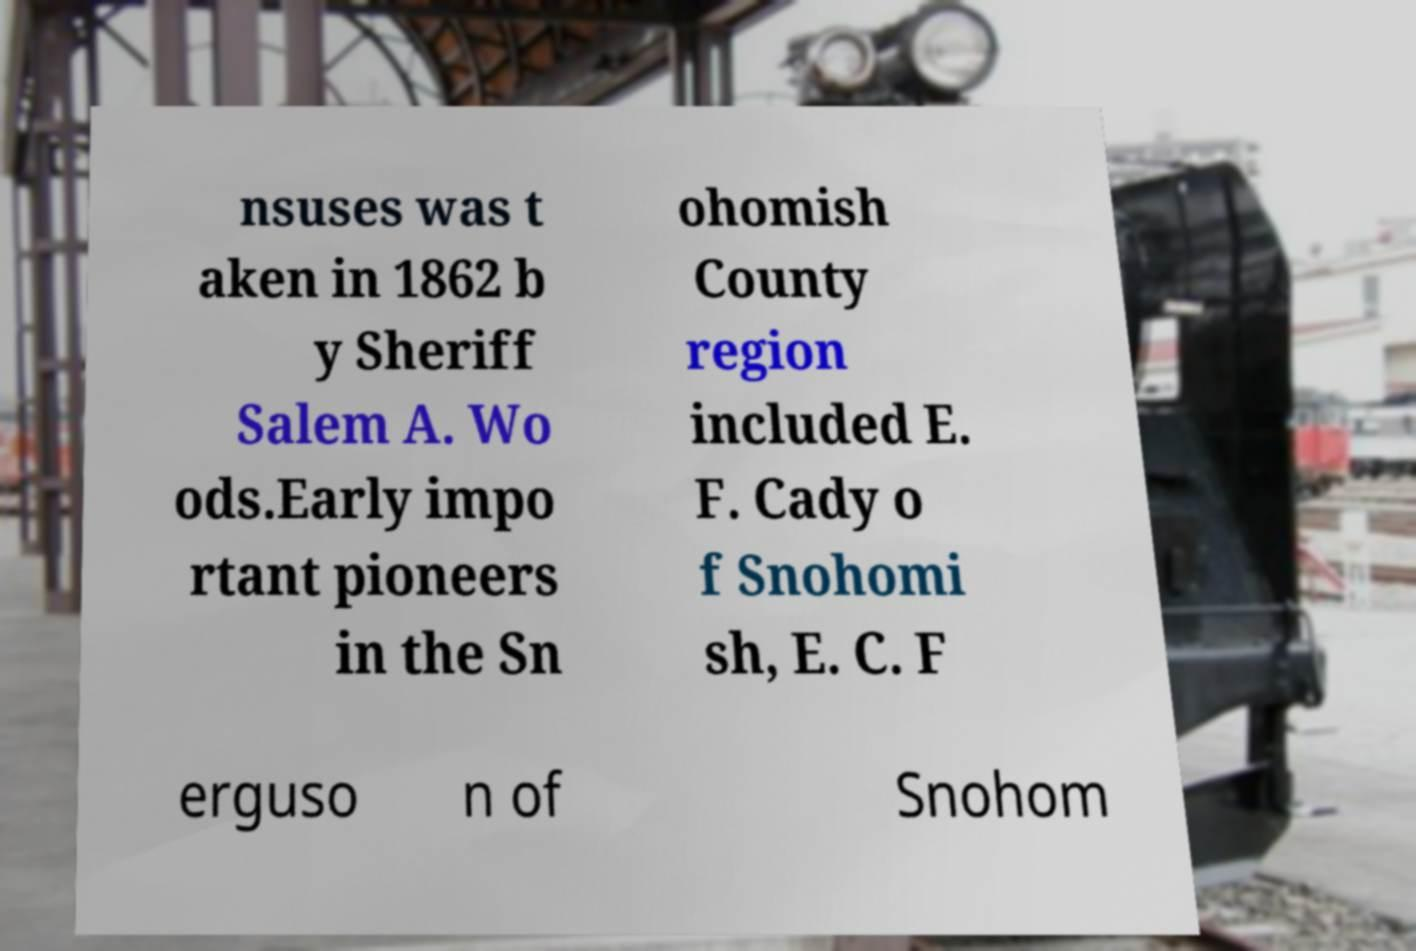Could you assist in decoding the text presented in this image and type it out clearly? nsuses was t aken in 1862 b y Sheriff Salem A. Wo ods.Early impo rtant pioneers in the Sn ohomish County region included E. F. Cady o f Snohomi sh, E. C. F erguso n of Snohom 